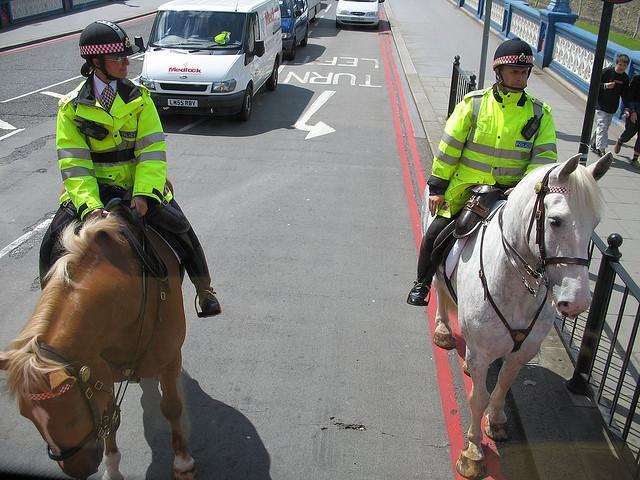How many horses are there?
Give a very brief answer. 2. How many people can be seen?
Give a very brief answer. 3. 